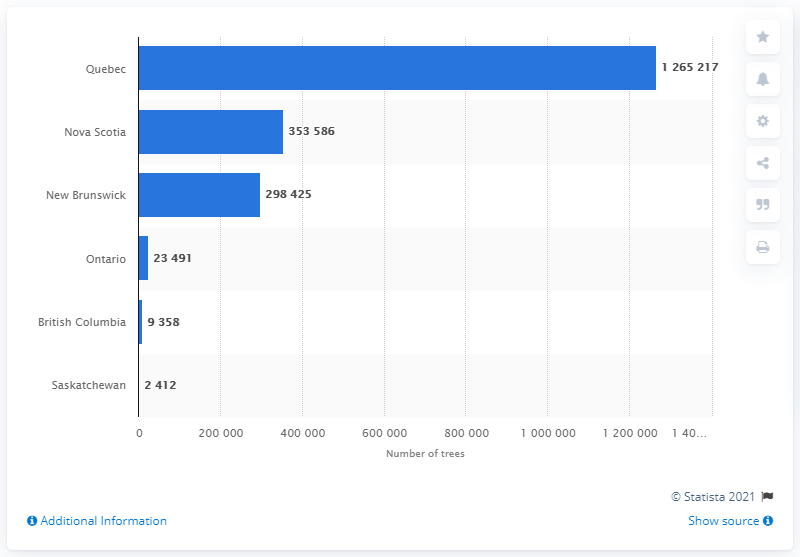Identify some key points in this picture. In the year 2019, a total of 23,491 Christmas trees were exported from the province of Ontario. In 2020, approximately 11,770 Christmas trees were exported from British Columbia and Saskatchewan. 